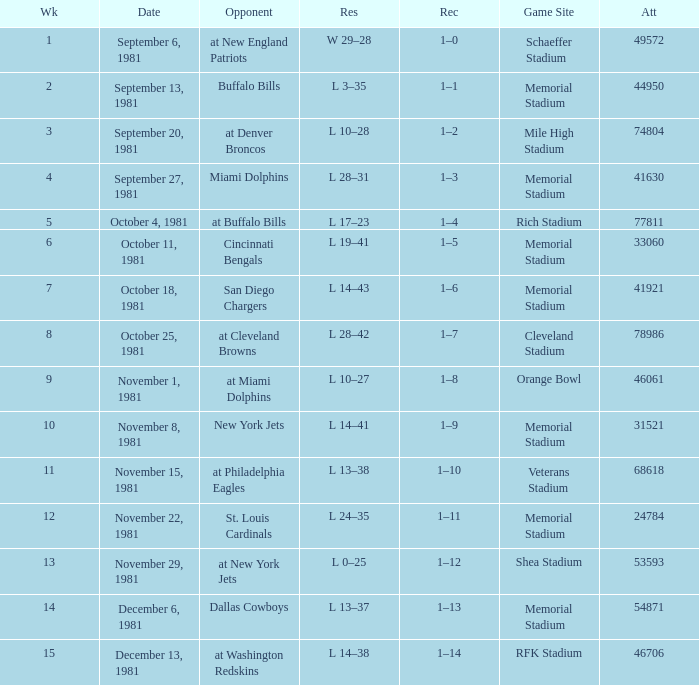When it is week 2 what is the record? 1–1. 